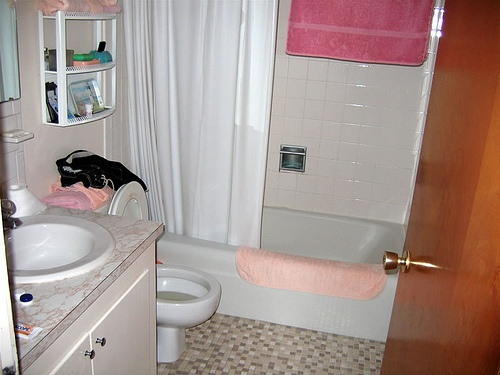Describe the objects in this image and their specific colors. I can see sink in gray, darkgray, and lightgray tones and toilet in gray, darkgray, and lightgray tones in this image. 